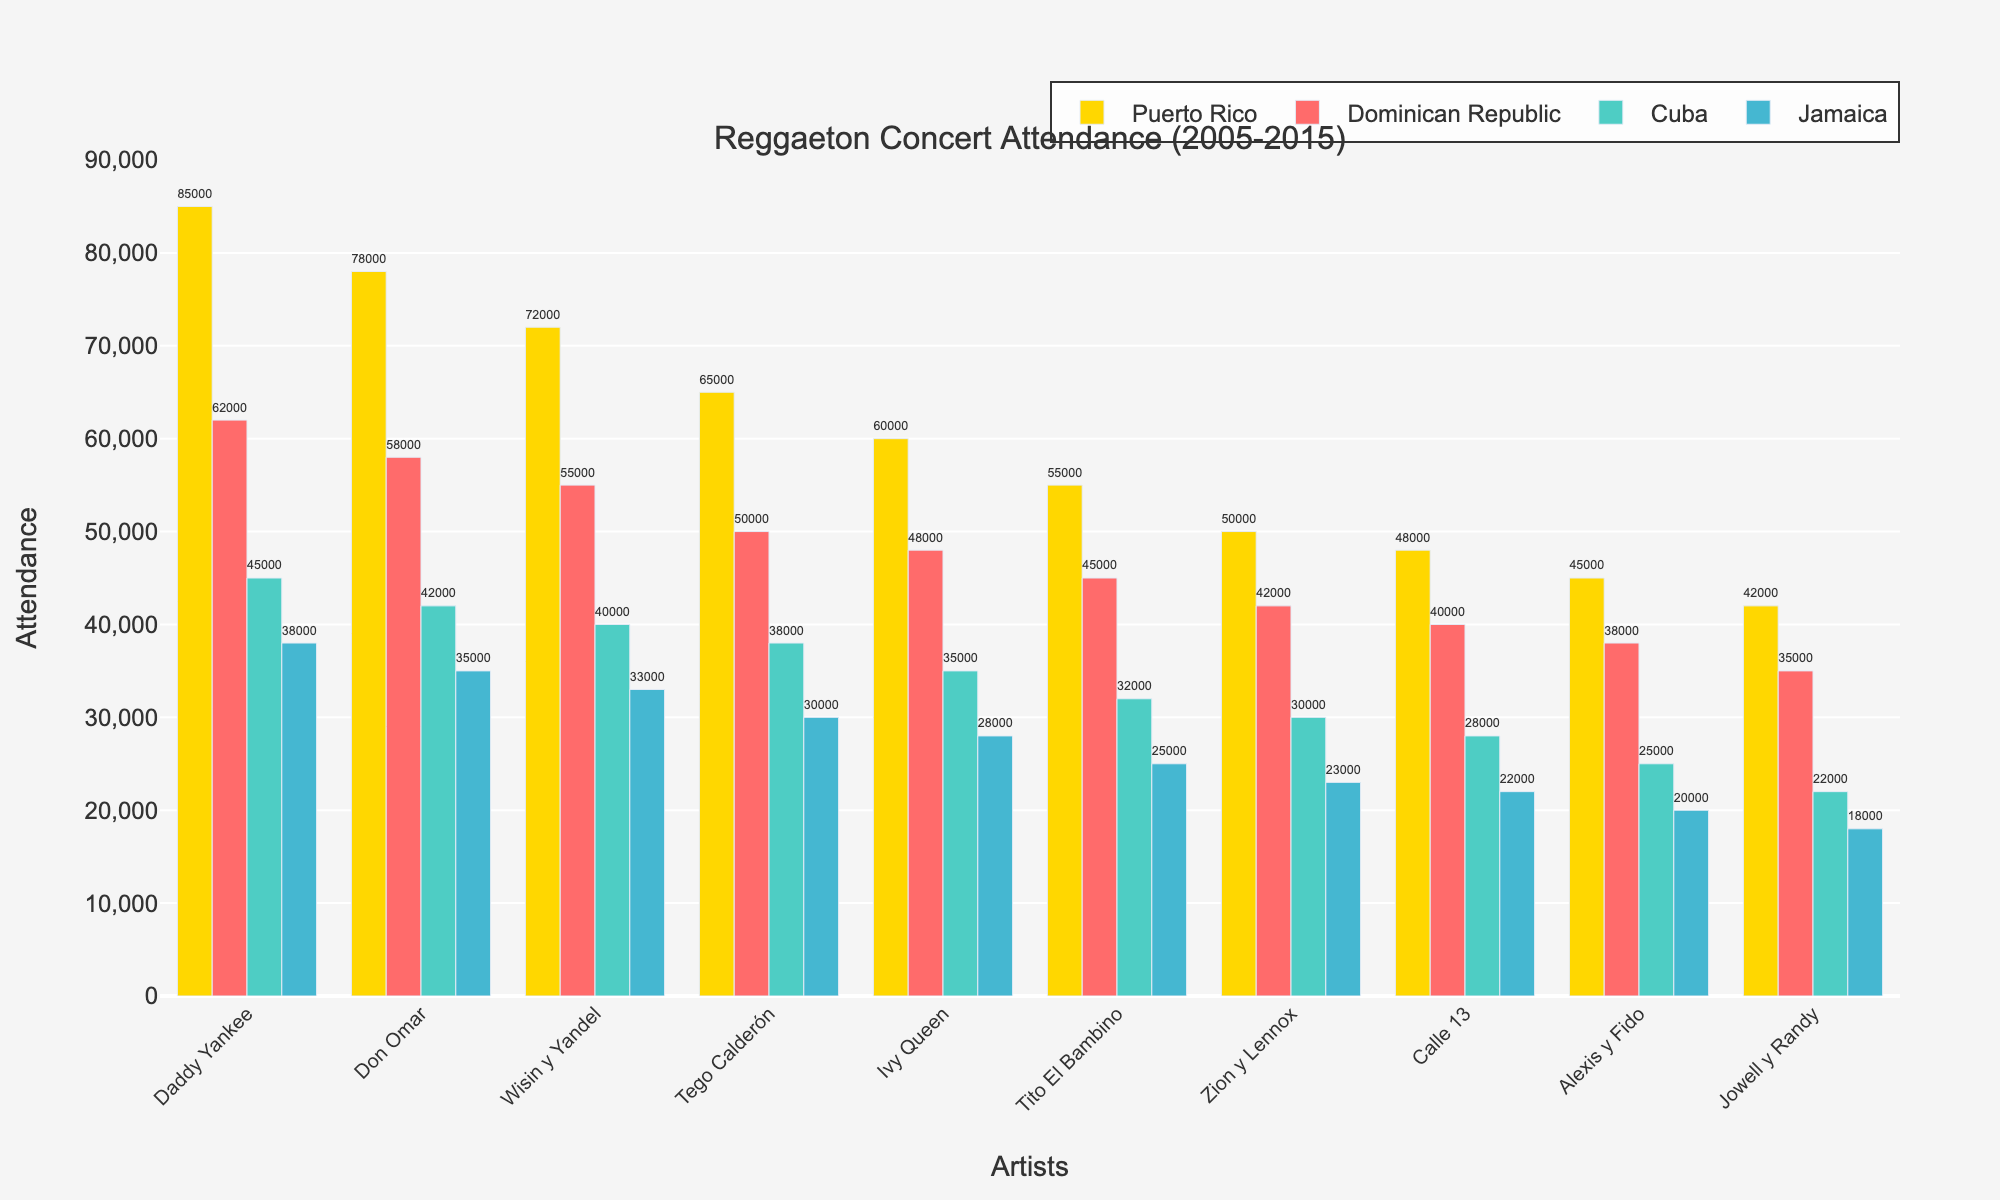Which artist had the highest concert attendance in Puerto Rico? Look at the bar heights for the Puerto Rico category and find the tallest one. This corresponds to Daddy Yankee.
Answer: Daddy Yankee How many more people attended Wisin y Yandel's concerts in Puerto Rico compared to Jamaica? Subtract the number of attendees in Jamaica (33,000) from the number of attendees in Puerto Rico (72,000). 72,000 - 33,000 = 39,000
Answer: 39,000 Which country had the lowest attendance for Ivy Queen's concerts? Locate the bar representing Ivy Queen and look for the shortest bar across all countries. The shortest bar is for Jamaica (28,000).
Answer: Jamaica What's the total concert attendance for Tego Calderón across all four countries? Sum the attendance numbers for Tego Calderón in each country: 65,000 (Puerto Rico) + 50,000 (Dominican Republic) + 38,000 (Cuba) + 30,000 (Jamaica) = 183,000
Answer: 183,000 Which artist had the smallest difference in attendance between Puerto Rico and the Dominican Republic? Calculate the differences for each artist: Daddy Yankee: 85,000 - 62,000 = 23,000, Don Omar: 78,000 - 58,000 = 20,000, Wisin y Yandel: 72,000 - 55,000 = 17,000, Tego Calderón: 65,000 - 50,000 = 15,000, Ivy Queen: 60,000 - 48,000 = 12,000, Tito El Bambino: 55,000 - 45,000 = 10,000, Zion y Lennox: 50,000 - 42,000 = 8,000, Calle 13: 48,000 - 40,000 = 8,000, Alexis y Fido: 45,000 - 38,000 = 7,000, Jowell y Randy: 42,000 - 35,000 = 7,000. So, Jowell y Randy and Alexis y Fido have the smallest difference.
Answer: Jowell y Randy and Alexis y Fido Which country shows the most significant decrease in attendance from Daddy Yankee to Jowell y Randy? Calculate the difference in attendance numbers from Daddy Yankee to Jowell y Randy for each country. For Puerto Rico: 85,000 - 42,000 = 43,000, for Dominican Republic: 62,000 - 35,000 = 27,000, for Cuba: 45,000 - 22,000 = 23,000, and for Jamaica: 38,000 - 18,000 = 20,000. Puerto Rico has the largest decrease.
Answer: Puerto Rico How many artists had a concert attendance of 50,000 or more in Cuba? Identify the bars in the Cuba category with heights 50,000 or more. Only Daddy Yankee (45,000) and Don Omar (42,000) fall short, so there are zero artists meeting this criterion.
Answer: 0 Which artist has more than double the attendance in Puerto Rico compared to Jamaica? Compare each artist's attendance in Puerto Rico to twice their attendance in Jamaica. For example, Daddy Yankee: 85,000 > 2*38,000 = 76,000, and so on for each artist. Only Daddy Yankee fits this description.
Answer: Daddy Yankee What's the average attendance for Tito El Bambino and Zion y Lennox in the Dominican Republic? Sum the attendance numbers: 45,000 (Tito El Bambino) + 42,000 (Zion y Lennox) = 87,000, then divide by 2 to find the average. 87,000 / 2 = 43,500
Answer: 43,500 